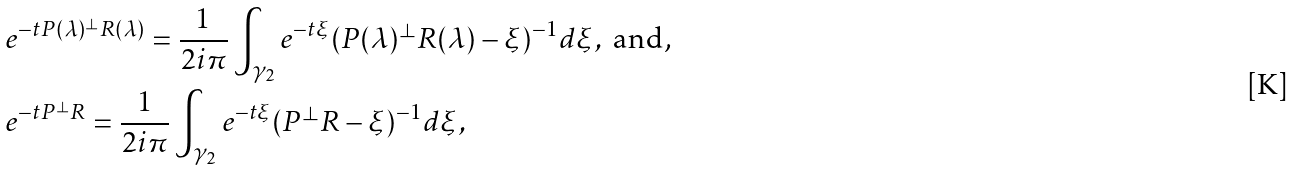<formula> <loc_0><loc_0><loc_500><loc_500>& e ^ { - t P ( \lambda ) ^ { \perp } R ( \lambda ) } = { \frac { 1 } { 2 i \pi } } \int _ { \gamma _ { 2 } } e ^ { - t \xi } ( P ( \lambda ) ^ { \perp } R ( \lambda ) - \xi ) ^ { - 1 } d \xi , \text { and, } \\ & e ^ { - t P ^ { \perp } R } = { \frac { 1 } { 2 i \pi } } \int _ { \gamma _ { 2 } } e ^ { - t \xi } ( P ^ { \perp } R - \xi ) ^ { - 1 } d \xi ,</formula> 